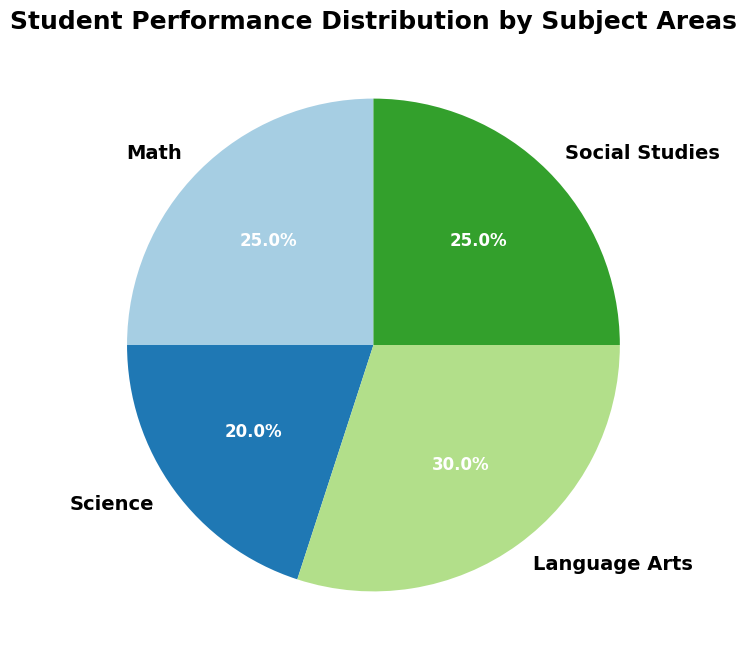What percentage of students perform in Science? Looking at the Science segment of the pie chart, it indicates 20%.
Answer: 20% Which two subjects have equal performance distribution percentages? From the pie chart, Math and Social Studies both show performance distribution percentages of 25%.
Answer: Math, Social Studies Which subject shows the highest student performance distribution? By comparing the percentages on the pie chart, Language Arts has the highest performance distribution at 30%.
Answer: Language Arts How much more is the performance distribution of Language Arts compared to Science? Language Arts is at 30% and Science at 20%. The difference is calculated as 30% - 20% = 10%.
Answer: 10% Calculate the total percentage for subjects with performance distribution greater than 20%. Math (25%), Language Arts (30%), and Social Studies (25%) together sum up to 25% + 30% + 25% = 80%.
Answer: 80% What is the combined performance distribution for Math and Social Studies? Both Math and Social Studies have a distribution of 25% each. Combining these gives 25% + 25% = 50%.
Answer: 50% Compare the performance distribution between Math and Language Arts. Math has a distribution of 25%, and Language Arts has 30%. Language Arts has 5% more than Math.
Answer: Language Arts has 5% more Which subject uses the most prominent color shade on the pie chart? The largest segment on the pie chart represents Language Arts at 30%. Thus, its color shade is the most prominent.
Answer: Language Arts 